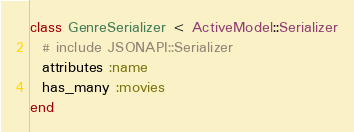Convert code to text. <code><loc_0><loc_0><loc_500><loc_500><_Ruby_>class GenreSerializer < ActiveModel::Serializer
  # include JSONAPI::Serializer
  attributes :name
  has_many :movies
end
</code> 